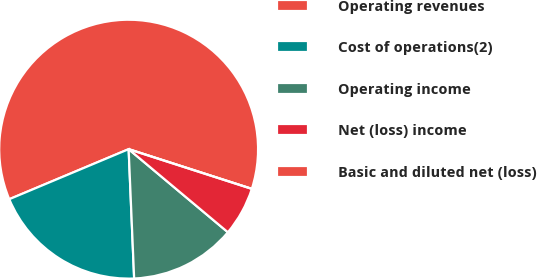<chart> <loc_0><loc_0><loc_500><loc_500><pie_chart><fcel>Operating revenues<fcel>Cost of operations(2)<fcel>Operating income<fcel>Net (loss) income<fcel>Basic and diluted net (loss)<nl><fcel>61.28%<fcel>19.36%<fcel>13.23%<fcel>6.13%<fcel>0.0%<nl></chart> 